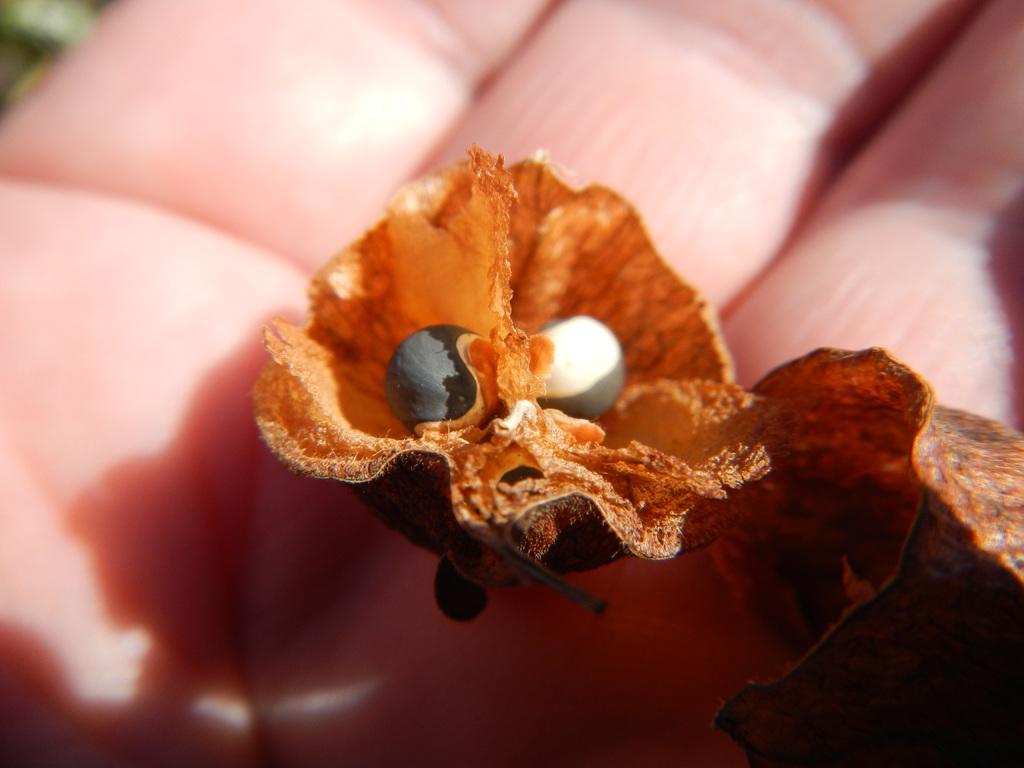Please provide a concise description of this image. In this image we can see flowers and a human hand. 